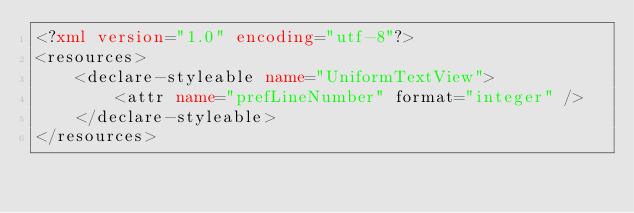Convert code to text. <code><loc_0><loc_0><loc_500><loc_500><_XML_><?xml version="1.0" encoding="utf-8"?>
<resources>
    <declare-styleable name="UniformTextView">
        <attr name="prefLineNumber" format="integer" />
    </declare-styleable>
</resources></code> 